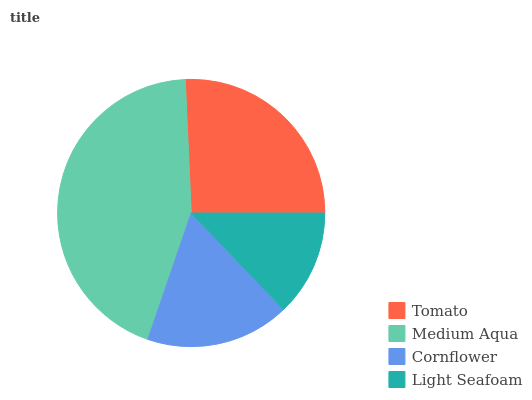Is Light Seafoam the minimum?
Answer yes or no. Yes. Is Medium Aqua the maximum?
Answer yes or no. Yes. Is Cornflower the minimum?
Answer yes or no. No. Is Cornflower the maximum?
Answer yes or no. No. Is Medium Aqua greater than Cornflower?
Answer yes or no. Yes. Is Cornflower less than Medium Aqua?
Answer yes or no. Yes. Is Cornflower greater than Medium Aqua?
Answer yes or no. No. Is Medium Aqua less than Cornflower?
Answer yes or no. No. Is Tomato the high median?
Answer yes or no. Yes. Is Cornflower the low median?
Answer yes or no. Yes. Is Cornflower the high median?
Answer yes or no. No. Is Tomato the low median?
Answer yes or no. No. 